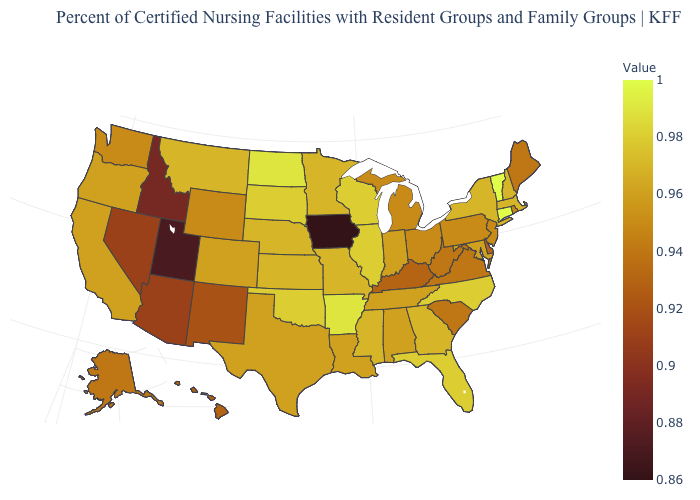Which states have the lowest value in the MidWest?
Quick response, please. Iowa. Does New Hampshire have the lowest value in the Northeast?
Write a very short answer. No. Does Massachusetts have a higher value than North Dakota?
Concise answer only. No. Among the states that border California , does Oregon have the highest value?
Short answer required. Yes. Which states have the highest value in the USA?
Give a very brief answer. Connecticut, Vermont. 